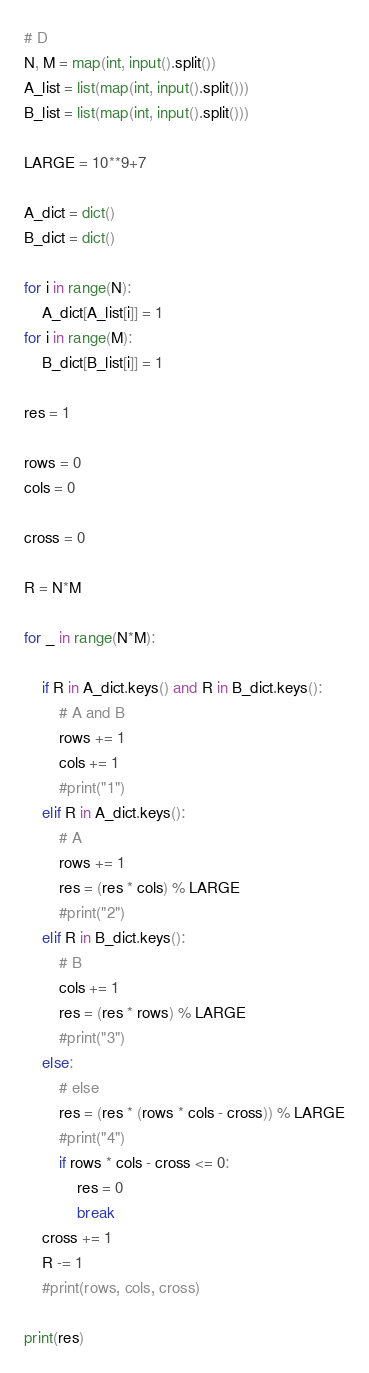<code> <loc_0><loc_0><loc_500><loc_500><_Python_># D
N, M = map(int, input().split())
A_list = list(map(int, input().split()))
B_list = list(map(int, input().split()))

LARGE = 10**9+7

A_dict = dict()
B_dict = dict()

for i in range(N):
    A_dict[A_list[i]] = 1
for i in range(M):
    B_dict[B_list[i]] = 1

res = 1

rows = 0
cols = 0

cross = 0

R = N*M

for _ in range(N*M):
    
    if R in A_dict.keys() and R in B_dict.keys():
        # A and B
        rows += 1
        cols += 1
        #print("1")
    elif R in A_dict.keys():
        # A
        rows += 1
        res = (res * cols) % LARGE
        #print("2")
    elif R in B_dict.keys():
        # B
        cols += 1
        res = (res * rows) % LARGE
        #print("3")
    else:
        # else
        res = (res * (rows * cols - cross)) % LARGE
        #print("4")
        if rows * cols - cross <= 0:
            res = 0
            break
    cross += 1
    R -= 1
    #print(rows, cols, cross)

print(res)</code> 